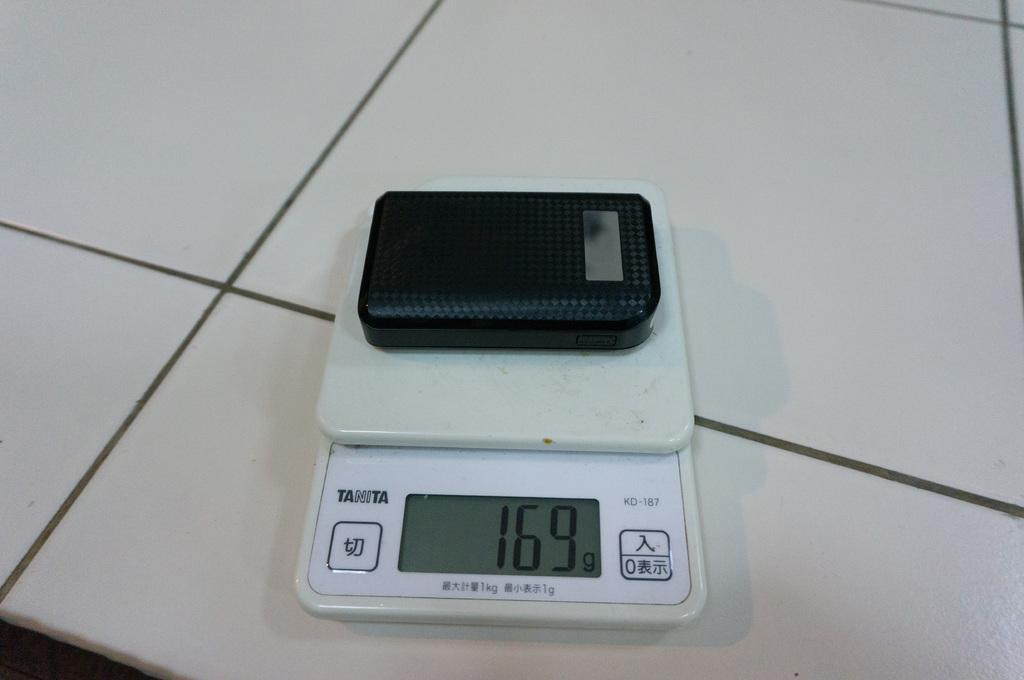<image>
Describe the image concisely. A Tanita brand scale has a display, which reads 169 grams. 